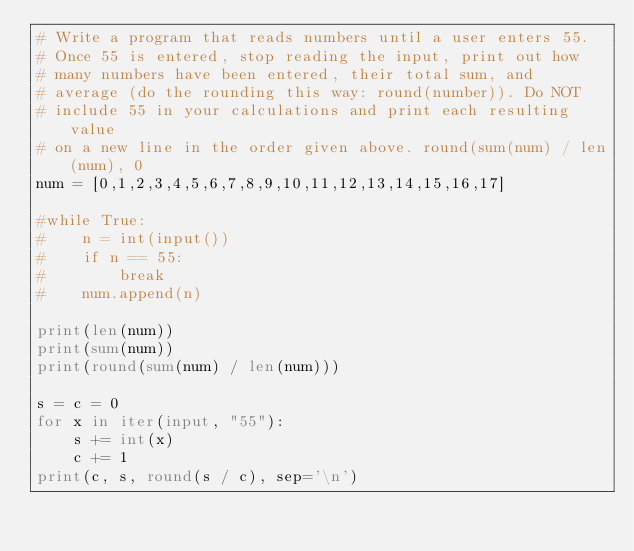Convert code to text. <code><loc_0><loc_0><loc_500><loc_500><_Python_># Write a program that reads numbers until a user enters 55.
# Once 55 is entered, stop reading the input, print out how
# many numbers have been entered, their total sum, and
# average (do the rounding this way: round(number)). Do NOT
# include 55 in your calculations and print each resulting value
# on a new line in the order given above. round(sum(num) / len(num), 0
num = [0,1,2,3,4,5,6,7,8,9,10,11,12,13,14,15,16,17]

#while True:
#    n = int(input())
#    if n == 55:
#        break
#    num.append(n)

print(len(num))
print(sum(num))
print(round(sum(num) / len(num)))

s = c = 0
for x in iter(input, "55"):
    s += int(x)
    c += 1
print(c, s, round(s / c), sep='\n')    </code> 